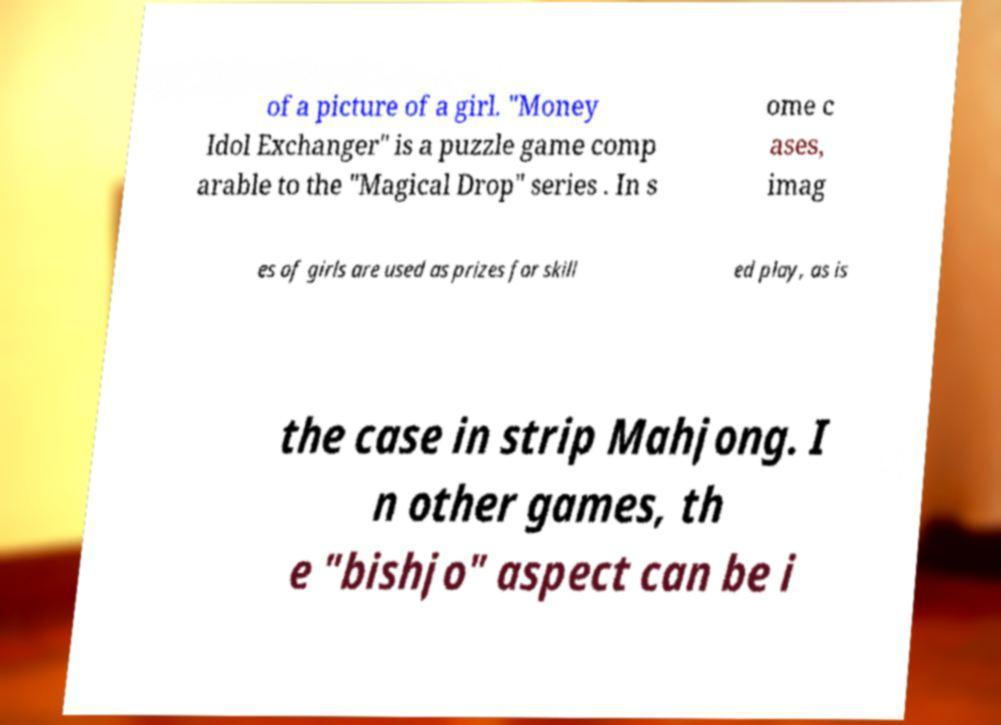I need the written content from this picture converted into text. Can you do that? of a picture of a girl. "Money Idol Exchanger" is a puzzle game comp arable to the "Magical Drop" series . In s ome c ases, imag es of girls are used as prizes for skill ed play, as is the case in strip Mahjong. I n other games, th e "bishjo" aspect can be i 